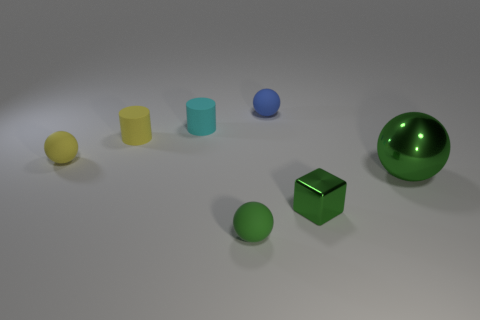What kind of environment do these objects seem to be in? The objects are in a neutral, nondescript environment that resembles a studio setup. The background is a gradient of light grays, which usually indicates a seamless backdrop. This type of environment is commonly used in product photography or visual experiments to keep the focus on the objects without any distractions from the surroundings. 